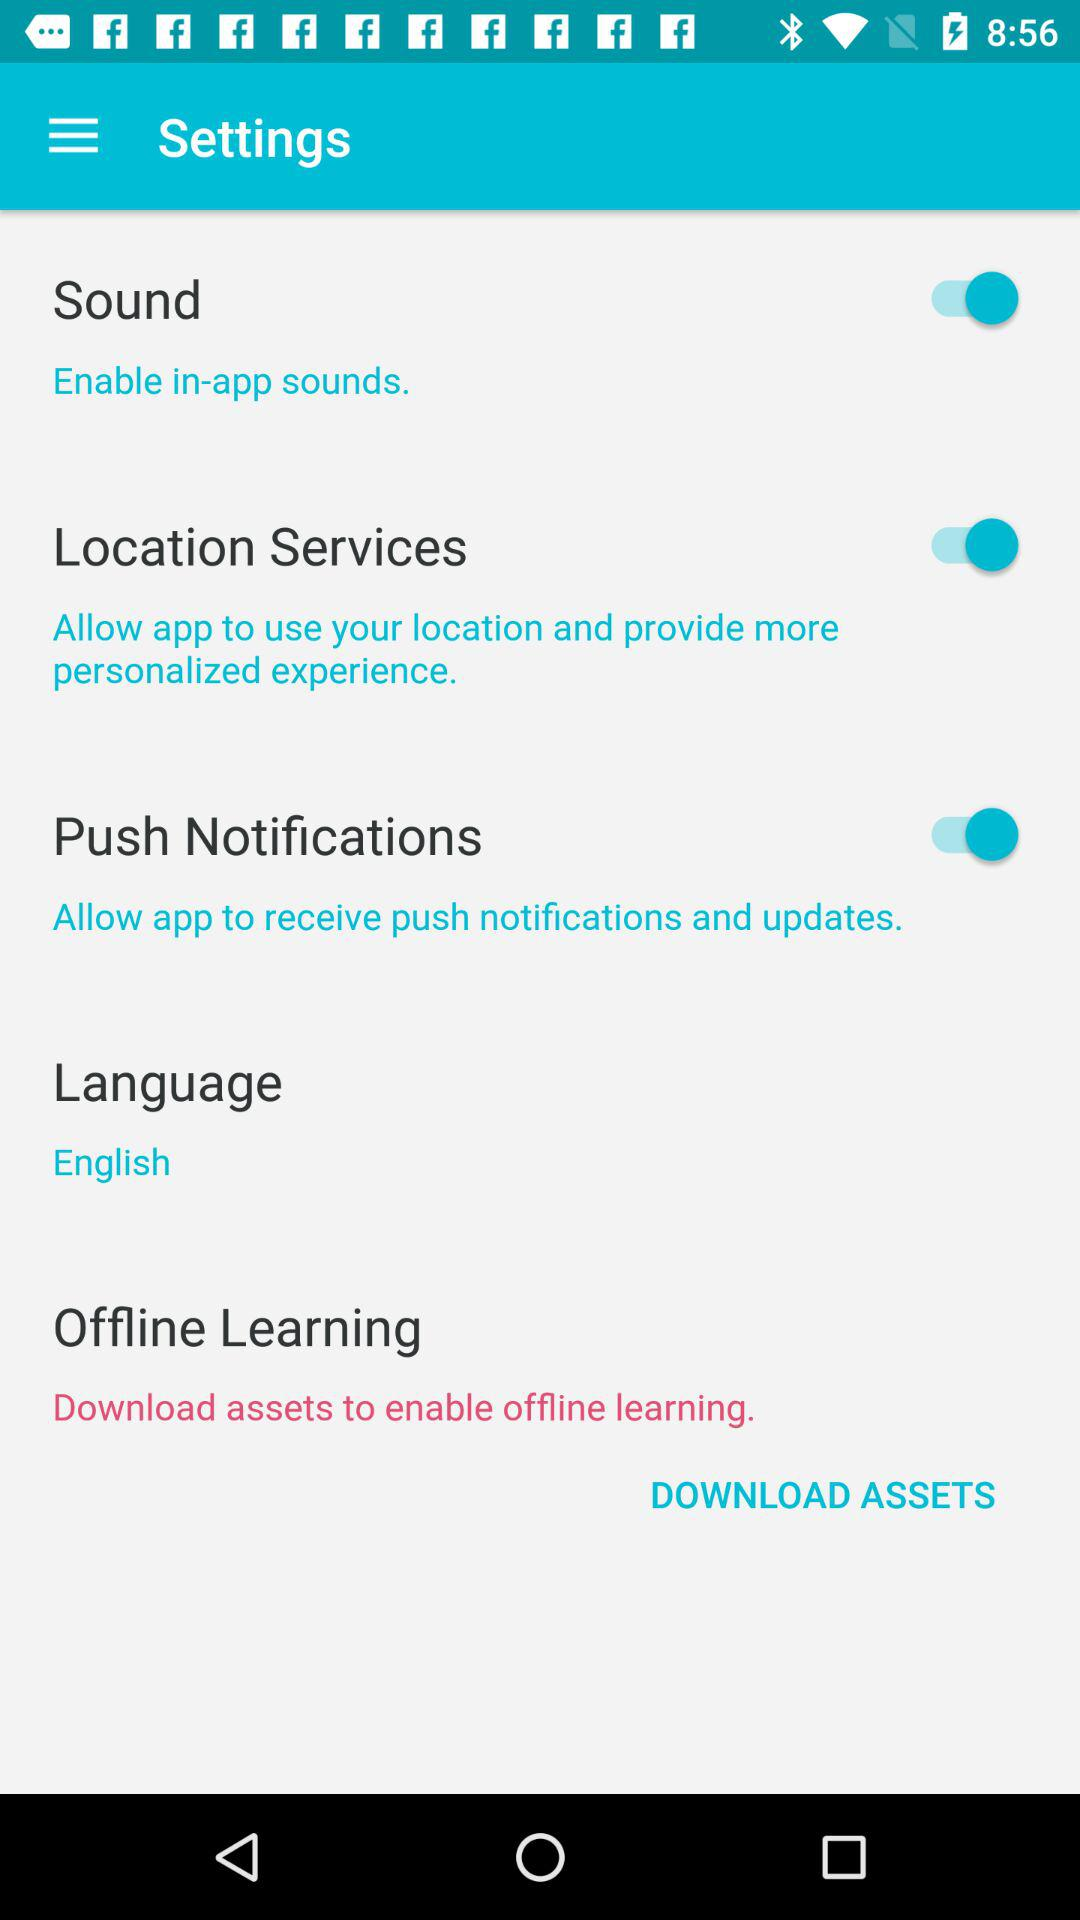What is the current status of the "Sound"? The current status is "on". 